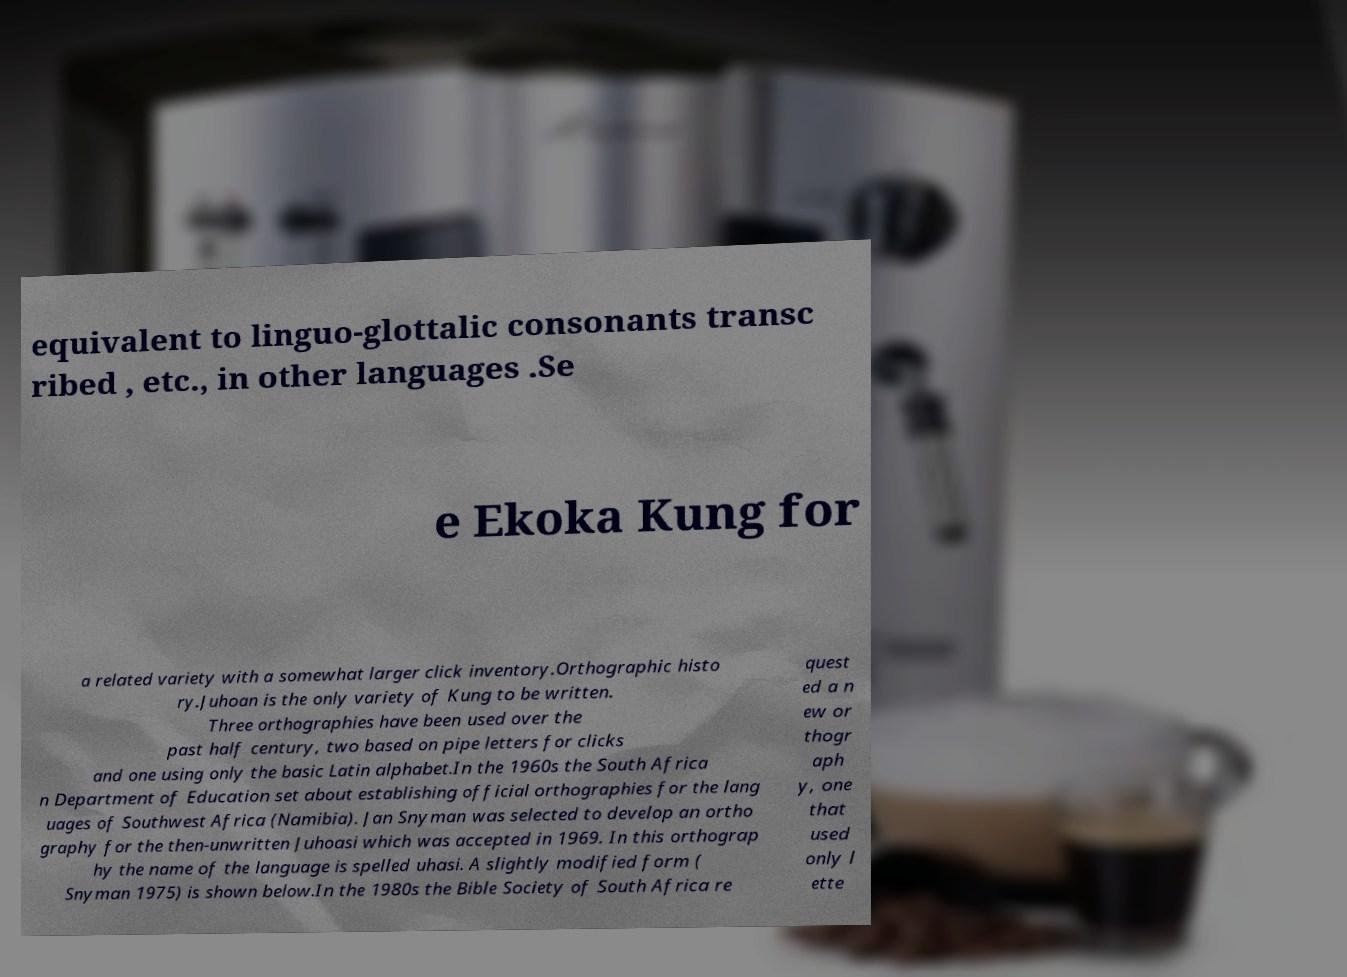There's text embedded in this image that I need extracted. Can you transcribe it verbatim? equivalent to linguo-glottalic consonants transc ribed , etc., in other languages .Se e Ekoka Kung for a related variety with a somewhat larger click inventory.Orthographic histo ry.Juhoan is the only variety of Kung to be written. Three orthographies have been used over the past half century, two based on pipe letters for clicks and one using only the basic Latin alphabet.In the 1960s the South Africa n Department of Education set about establishing official orthographies for the lang uages of Southwest Africa (Namibia). Jan Snyman was selected to develop an ortho graphy for the then-unwritten Juhoasi which was accepted in 1969. In this orthograp hy the name of the language is spelled uhasi. A slightly modified form ( Snyman 1975) is shown below.In the 1980s the Bible Society of South Africa re quest ed a n ew or thogr aph y, one that used only l ette 